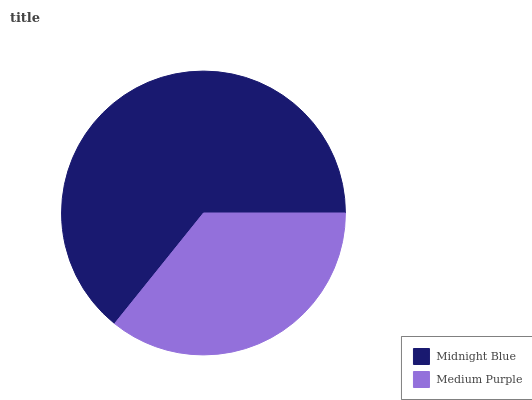Is Medium Purple the minimum?
Answer yes or no. Yes. Is Midnight Blue the maximum?
Answer yes or no. Yes. Is Medium Purple the maximum?
Answer yes or no. No. Is Midnight Blue greater than Medium Purple?
Answer yes or no. Yes. Is Medium Purple less than Midnight Blue?
Answer yes or no. Yes. Is Medium Purple greater than Midnight Blue?
Answer yes or no. No. Is Midnight Blue less than Medium Purple?
Answer yes or no. No. Is Midnight Blue the high median?
Answer yes or no. Yes. Is Medium Purple the low median?
Answer yes or no. Yes. Is Medium Purple the high median?
Answer yes or no. No. Is Midnight Blue the low median?
Answer yes or no. No. 